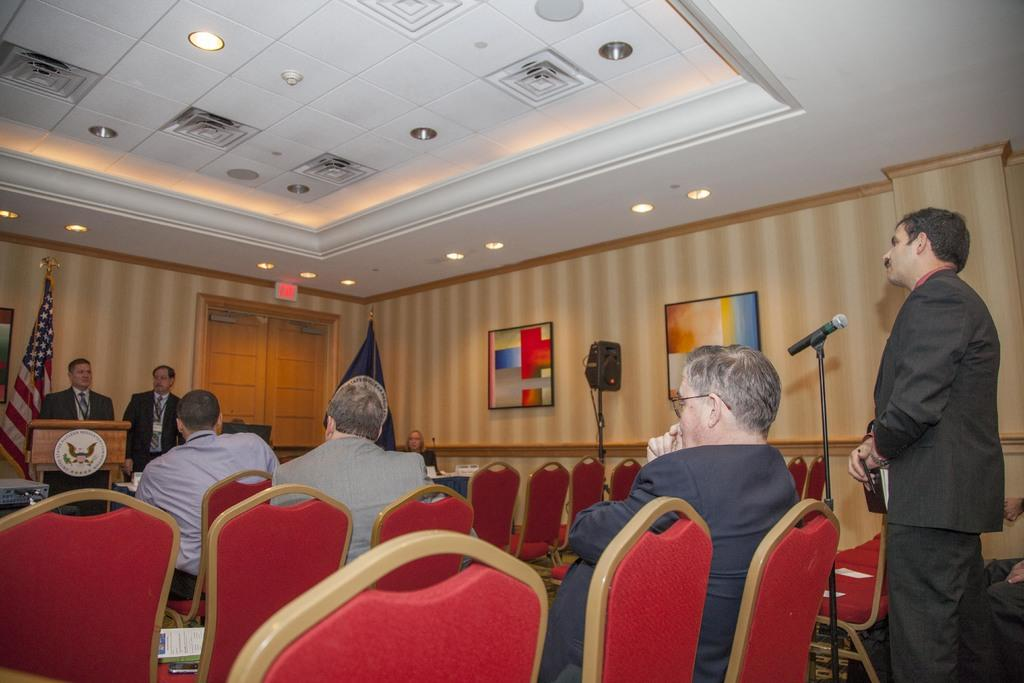What is the position of the man on the right side of the image? There is a man standing on the right side of the image. What are the two people in the middle of the image doing? Two people are sitting in chairs in the middle of the image. What can be seen on the roof in the image? There are lights on the roof. What is the man on the left side of the image doing? There is a man standing near a podium on the left side of the image. What time of day is depicted in the scene? The provided facts do not mention the time of day, so it cannot be determined from the image. What type of home is shown in the image? There is no home present in the image; it features people and a podium. 